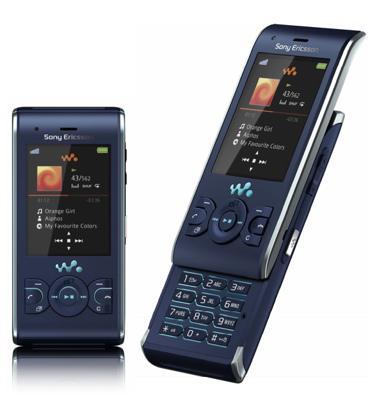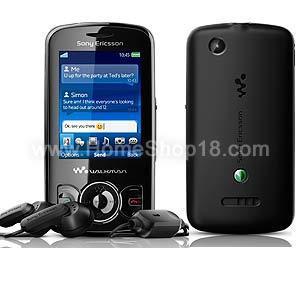The first image is the image on the left, the second image is the image on the right. Given the left and right images, does the statement "A yellow cellphone has a visible black antena in one of the images." hold true? Answer yes or no. No. The first image is the image on the left, the second image is the image on the right. Assess this claim about the two images: "One of the cell phones is yellow with a short black antenna.". Correct or not? Answer yes or no. No. 